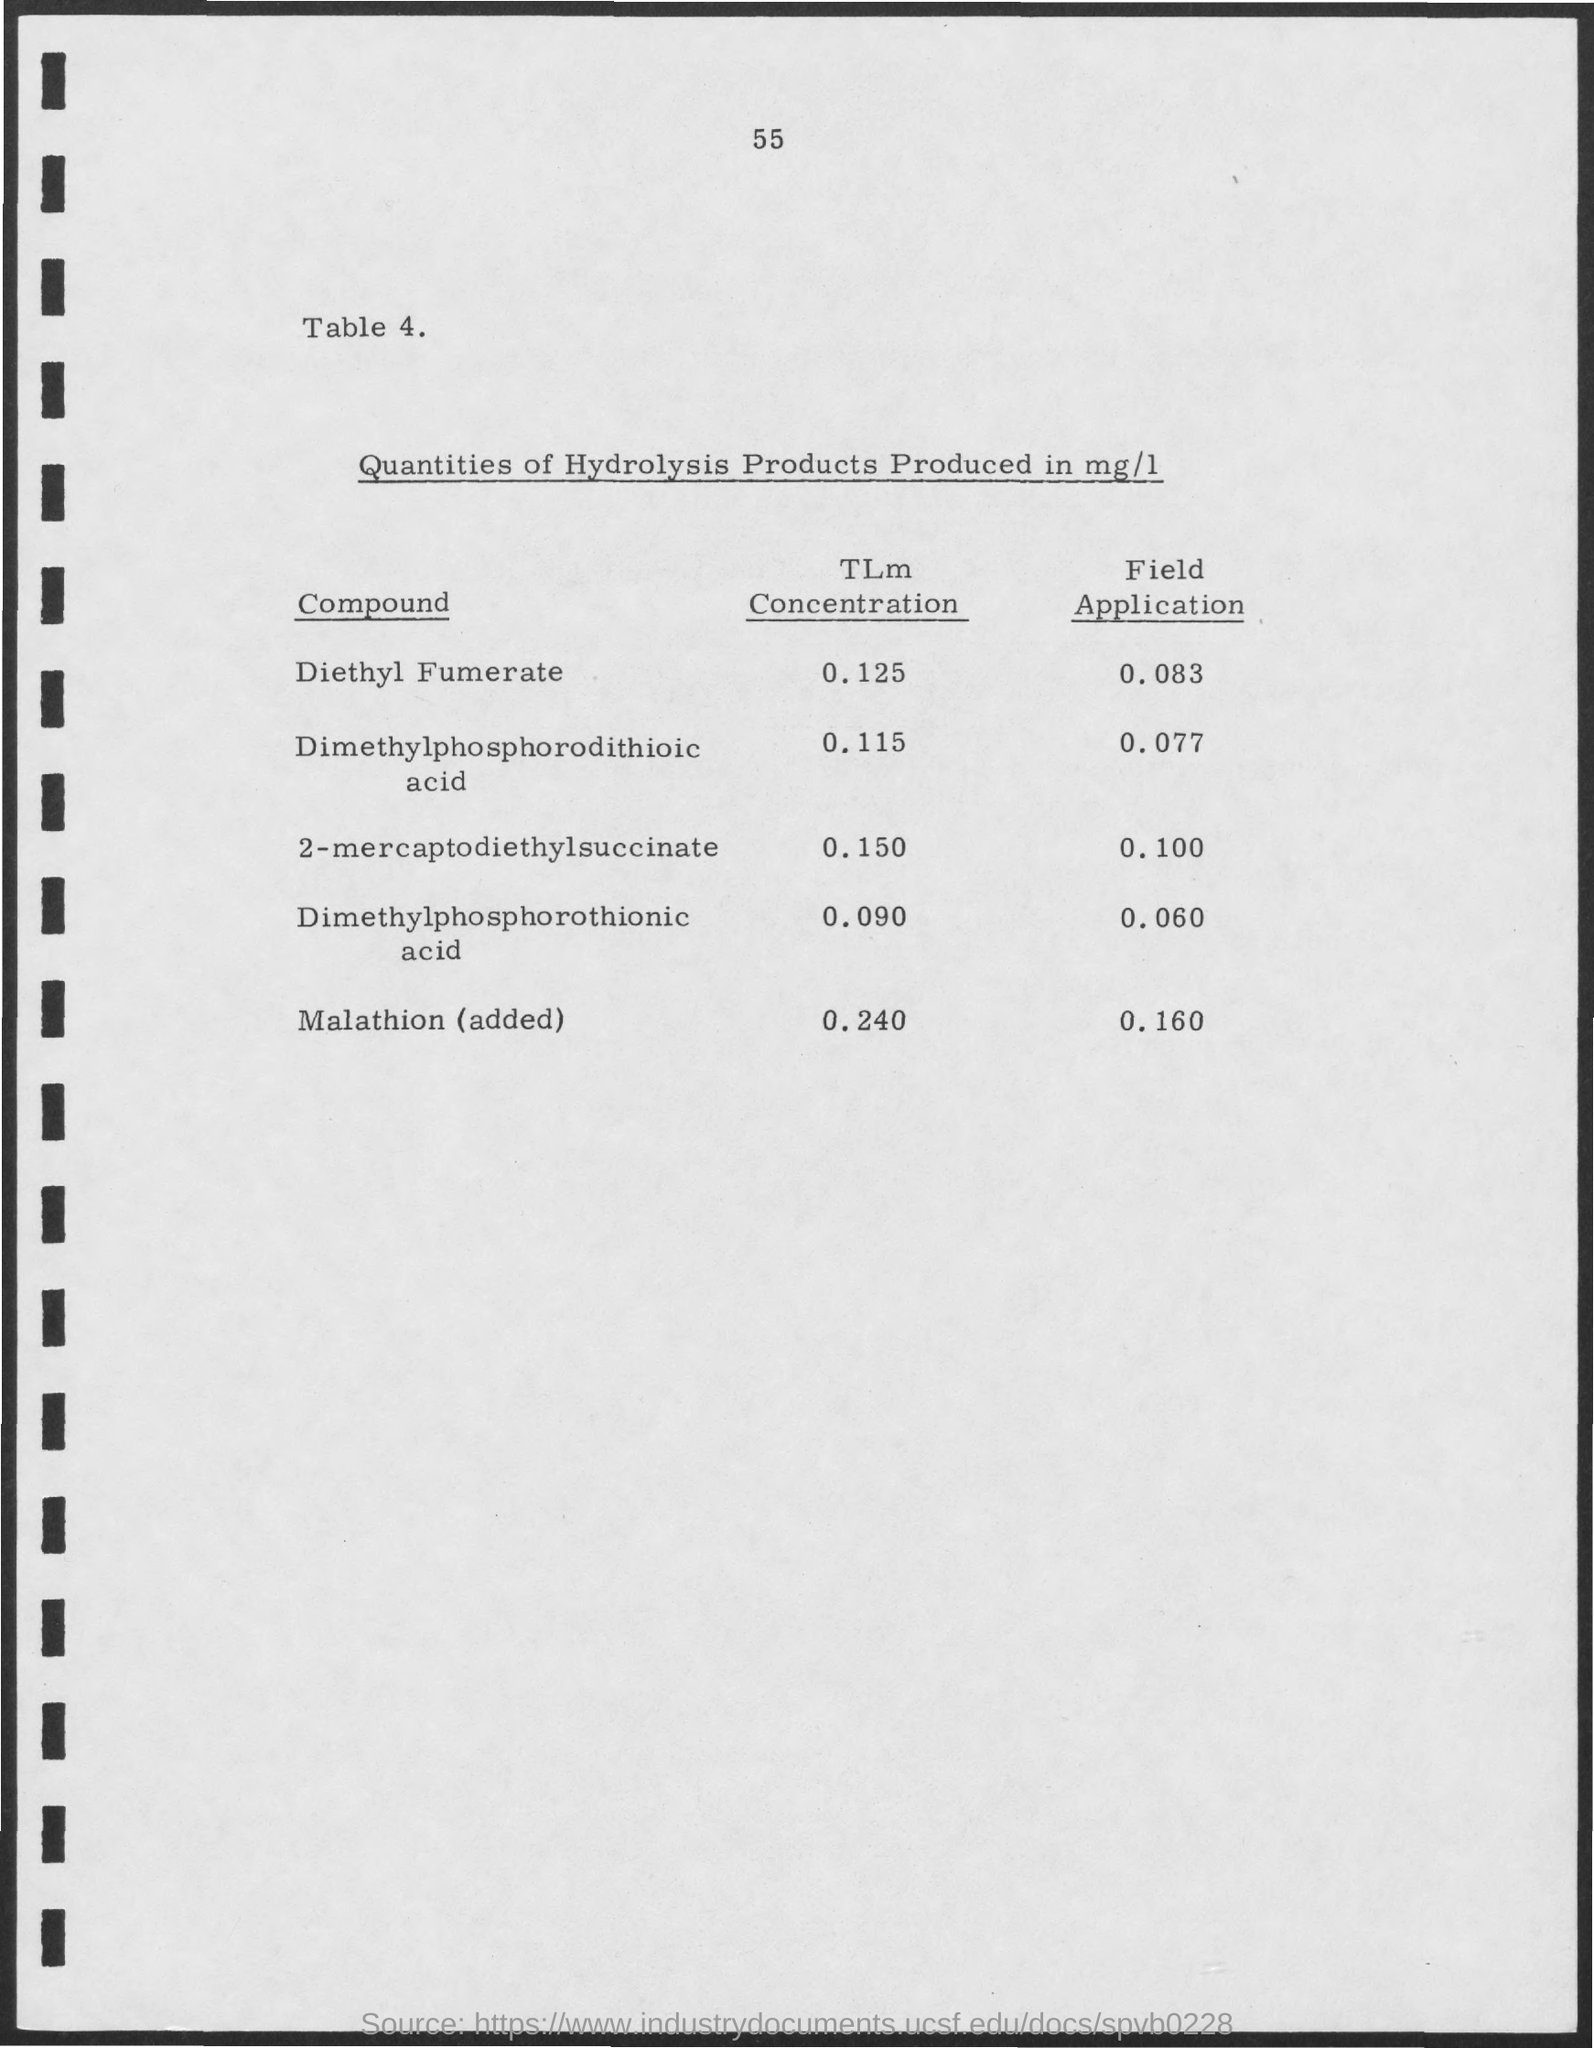What is the Table number?
Your response must be concise. 4. What is the TLm Concentration for Diethyl Fumerate?
Make the answer very short. 0.125. What is the TLm Concentration for 2-mercaptodiethylsuccinate?
Your answer should be compact. 0.150. What is the TLm Concentration for malathion (added)?
Offer a very short reply. 0.240. What is the Field Application for 2-mercaptodiethylsuccinate?
Ensure brevity in your answer.  0.100. What is the Field Application for Dimethylphosphorodithioic acid?
Offer a very short reply. 0.077. What is the Field Application for malathion (added)?
Ensure brevity in your answer.  0.160. What is the Page Number?
Ensure brevity in your answer.  55. 